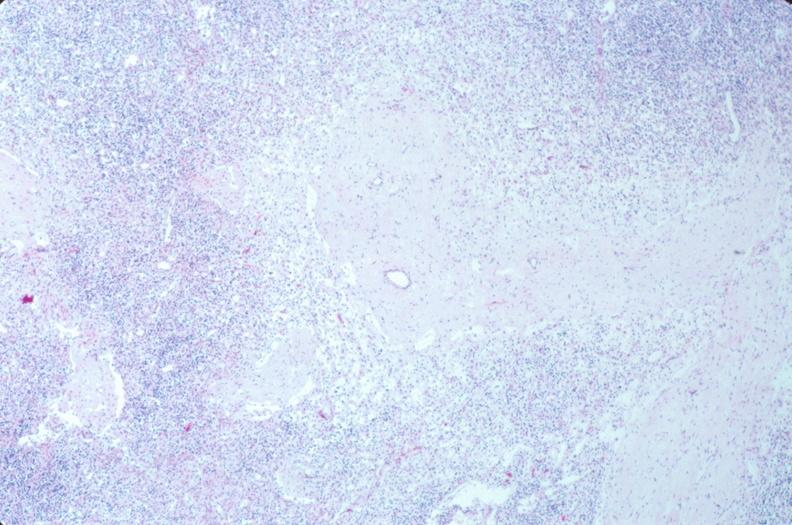does this image show lymph nodes, nodular sclerosing hodgkins disease?
Answer the question using a single word or phrase. Yes 